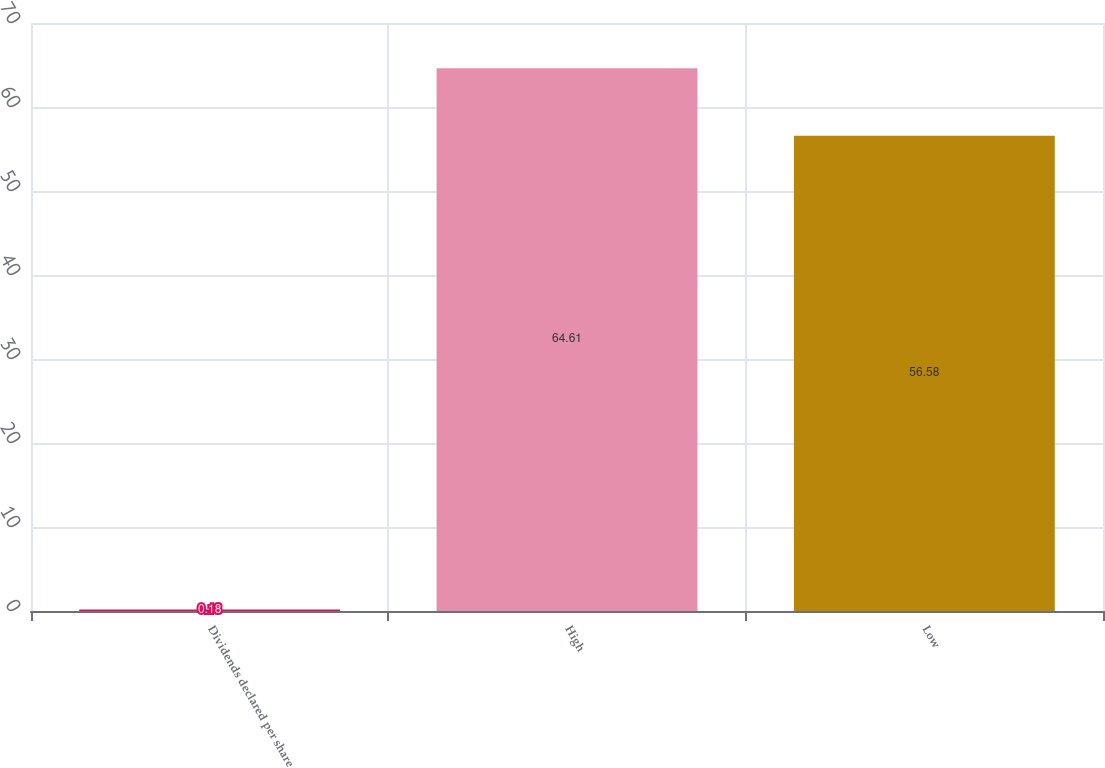Convert chart. <chart><loc_0><loc_0><loc_500><loc_500><bar_chart><fcel>Dividends declared per share<fcel>High<fcel>Low<nl><fcel>0.18<fcel>64.61<fcel>56.58<nl></chart> 